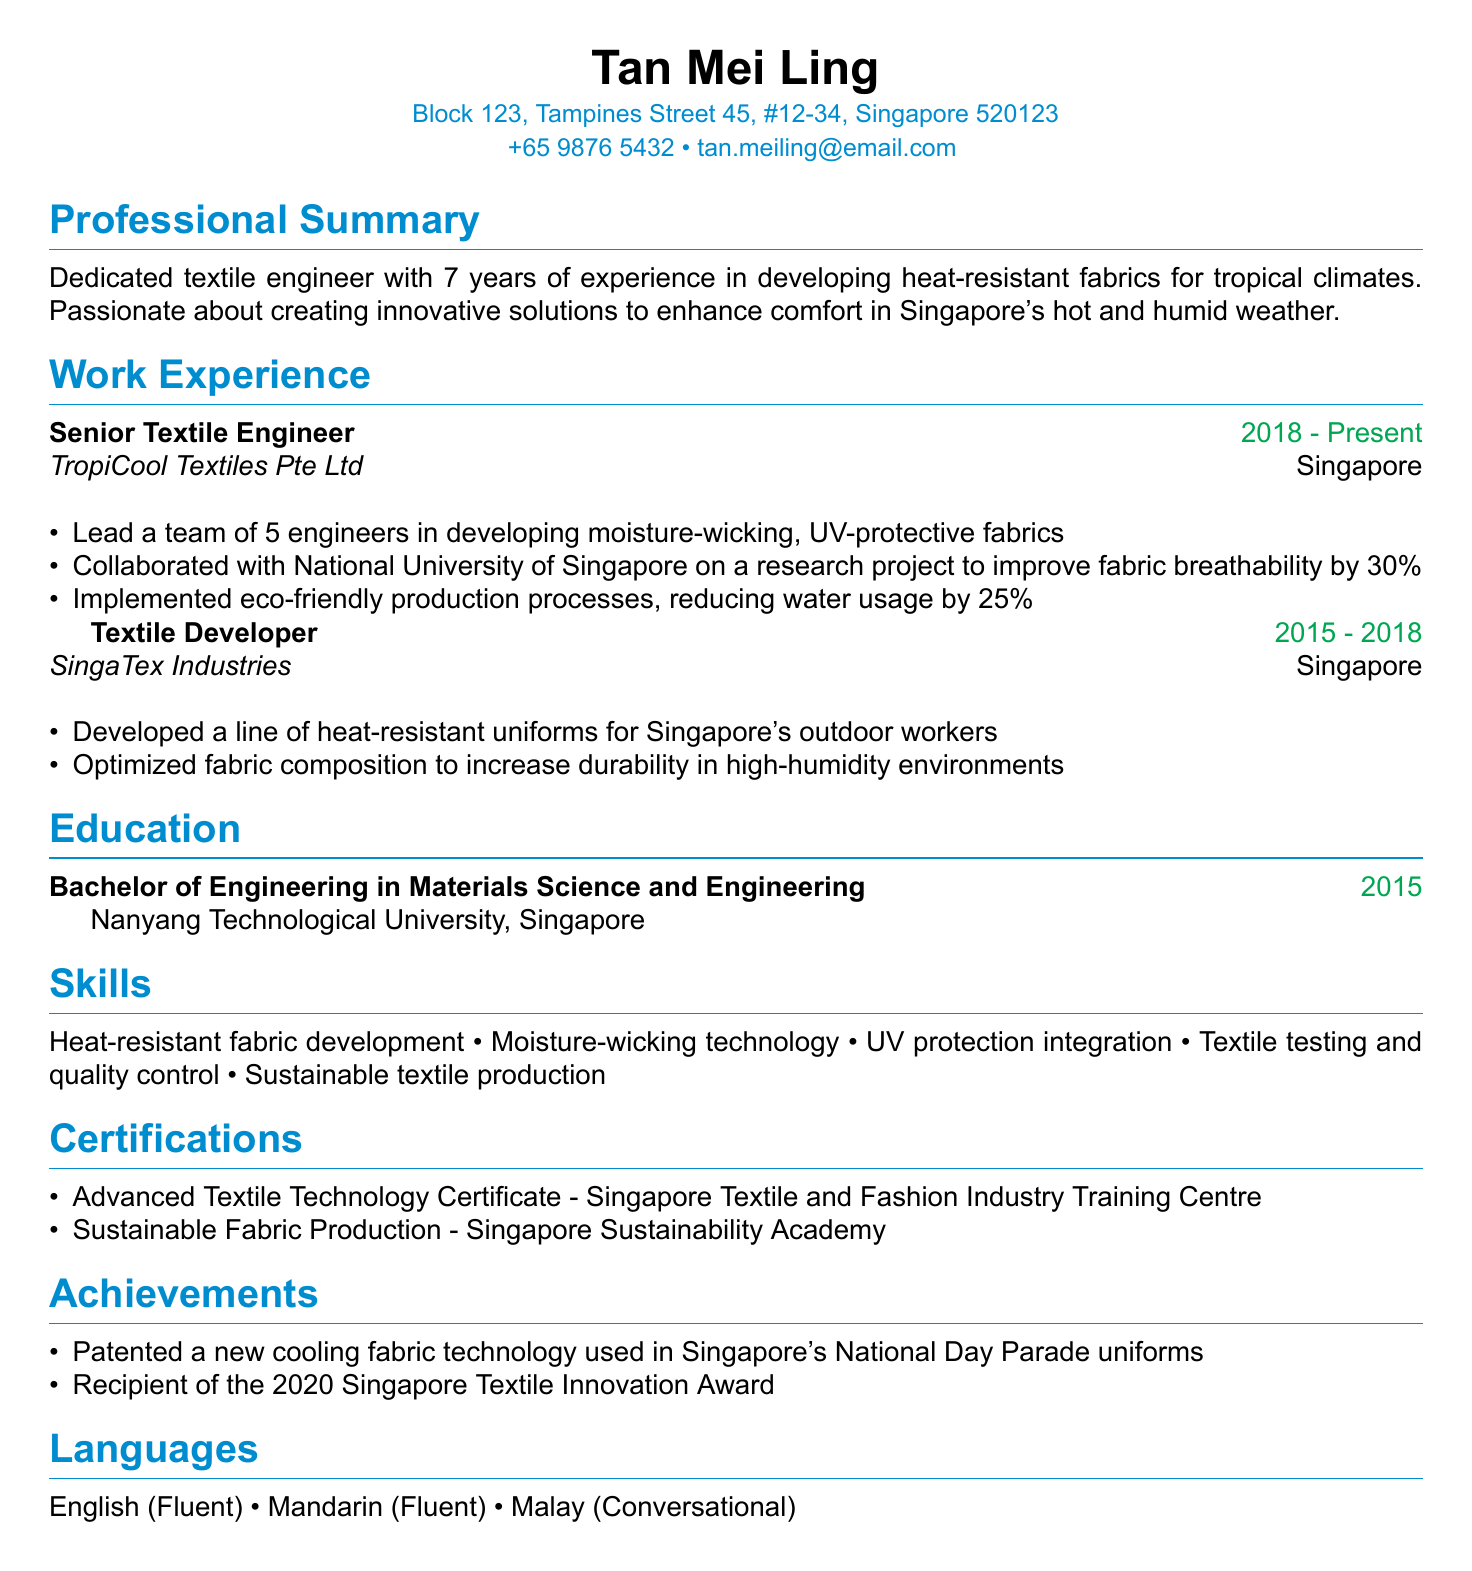What is the name of the candidate? The candidate's name is listed at the top of the document.
Answer: Tan Mei Ling What company does Tan Mei Ling currently work for? The current employer is noted in the work experience section.
Answer: TropiCool Textiles Pte Ltd How many years of experience does Tan Mei Ling have? The professional summary indicates the total years of experience.
Answer: 7 years What is the most recent job title held by Tan Mei Ling? The job title is specified in the work experience section.
Answer: Senior Textile Engineer Which university did Tan Mei Ling graduate from? The education section mentions the institution where she studied.
Answer: Nanyang Technological University What award did Tan Mei Ling receive in 2020? The achievements section outlines significant recognition received.
Answer: Singapore Textile Innovation Award How many engineers did Tan Mei Ling lead in her current role? The responsibilities of her current position detail her management role.
Answer: 5 engineers What type of fabric technology did Tan Mei Ling patent? The achievements section specifies the technology she has patented.
Answer: Cooling fabric technology What certification is related to sustainable fabric production? The certifications section lists the relevant certification.
Answer: Sustainable Fabric Production In how many languages is Tan Mei Ling fluent? The languages section indicates her fluency levels in multiple languages.
Answer: 2 languages 